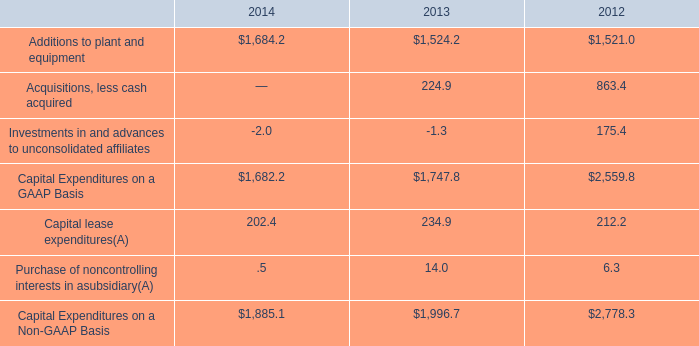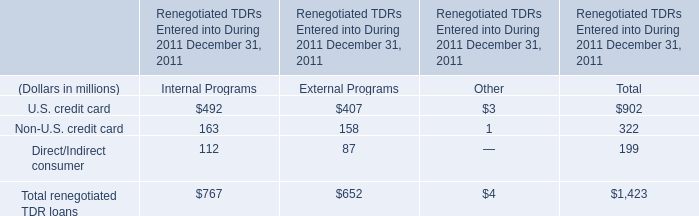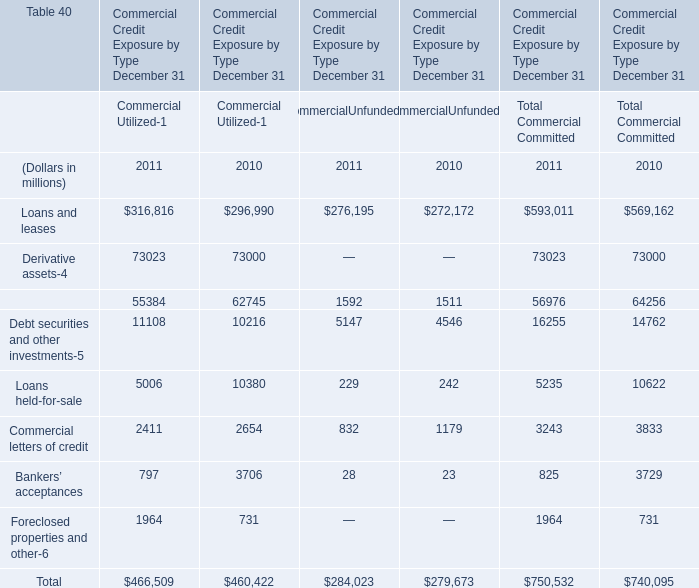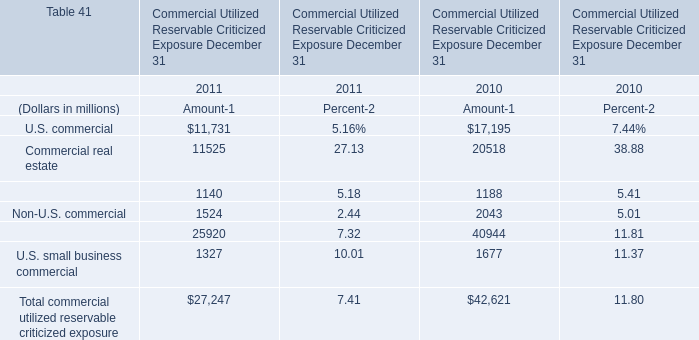What's the average of Loans and leases and Derivative assets and Loans held-for-sale in 2011? (in million) 
Computations: (((593011 + 73023) + 5235) / 3)
Answer: 223756.33333. 